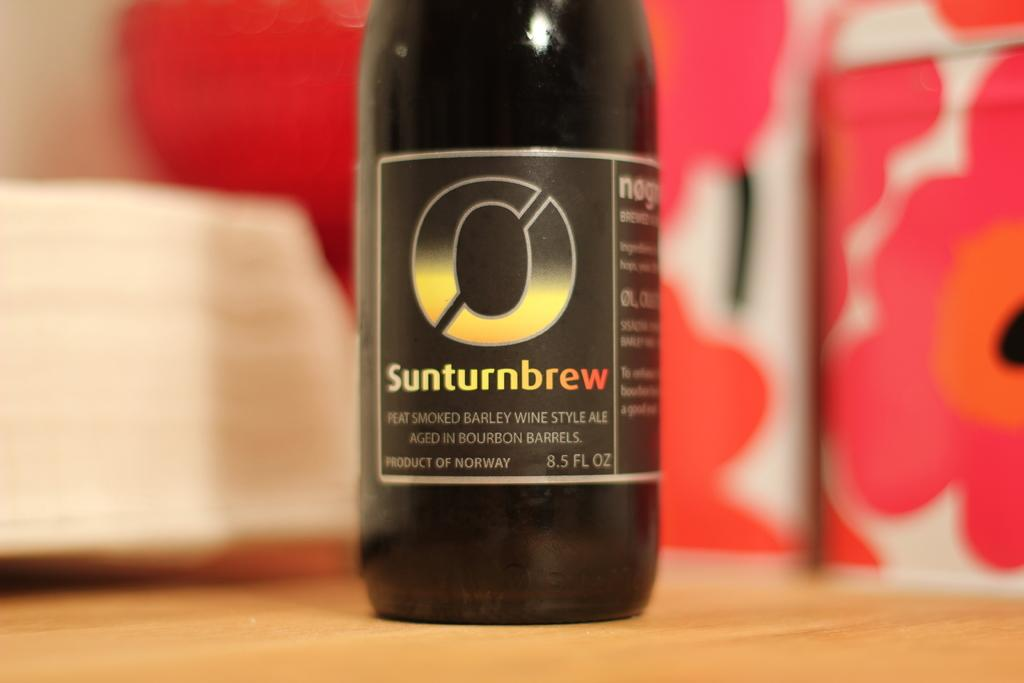Provide a one-sentence caption for the provided image. A bottle of ale with a smoked barley wine style. 